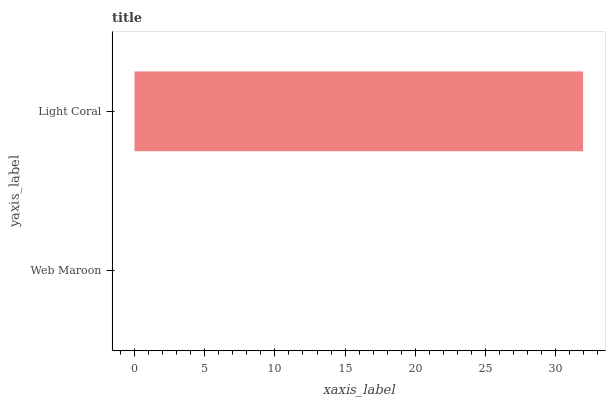Is Web Maroon the minimum?
Answer yes or no. Yes. Is Light Coral the maximum?
Answer yes or no. Yes. Is Light Coral the minimum?
Answer yes or no. No. Is Light Coral greater than Web Maroon?
Answer yes or no. Yes. Is Web Maroon less than Light Coral?
Answer yes or no. Yes. Is Web Maroon greater than Light Coral?
Answer yes or no. No. Is Light Coral less than Web Maroon?
Answer yes or no. No. Is Light Coral the high median?
Answer yes or no. Yes. Is Web Maroon the low median?
Answer yes or no. Yes. Is Web Maroon the high median?
Answer yes or no. No. Is Light Coral the low median?
Answer yes or no. No. 